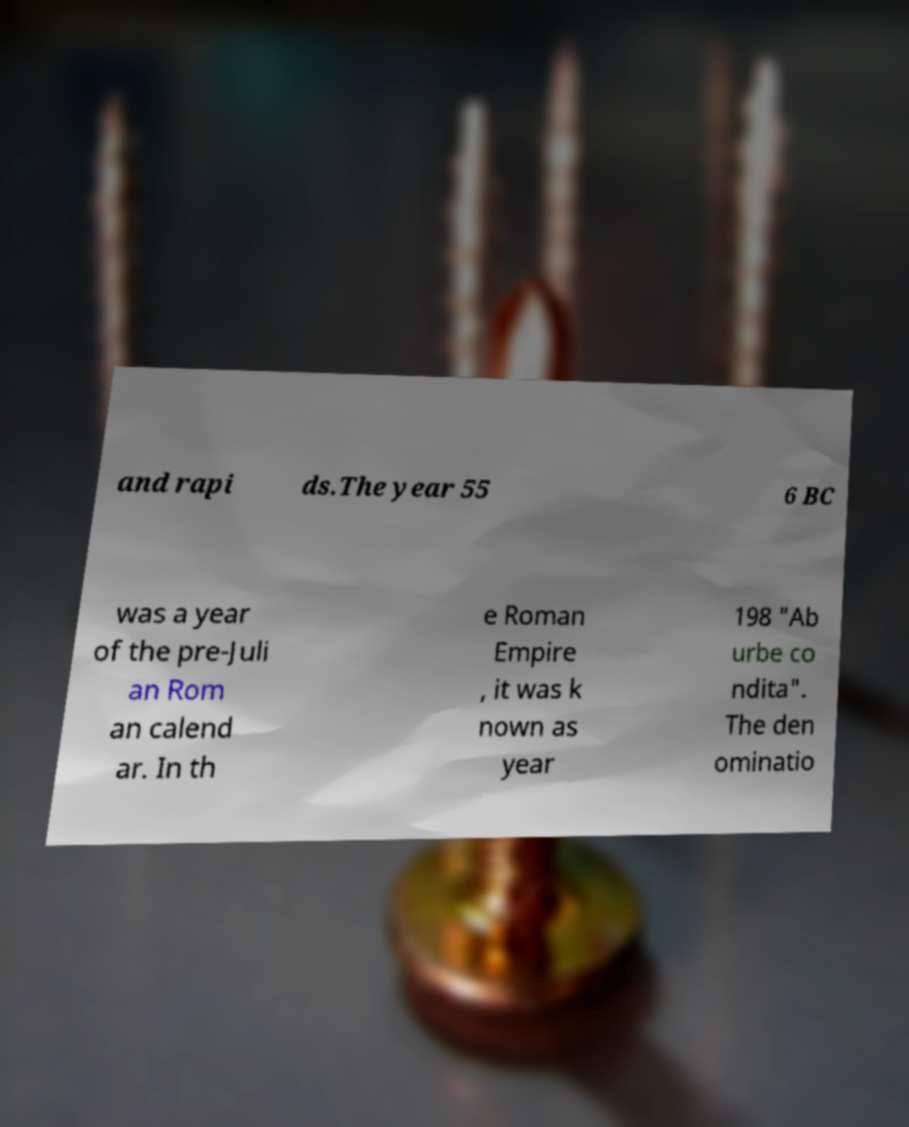For documentation purposes, I need the text within this image transcribed. Could you provide that? and rapi ds.The year 55 6 BC was a year of the pre-Juli an Rom an calend ar. In th e Roman Empire , it was k nown as year 198 "Ab urbe co ndita". The den ominatio 